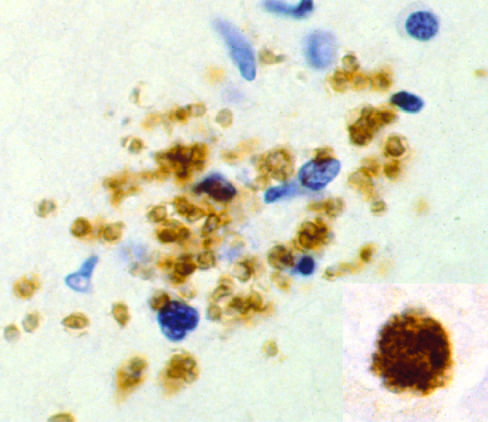what are bradyzoites present as?
Answer the question using a single word or phrase. Pseudocyst 